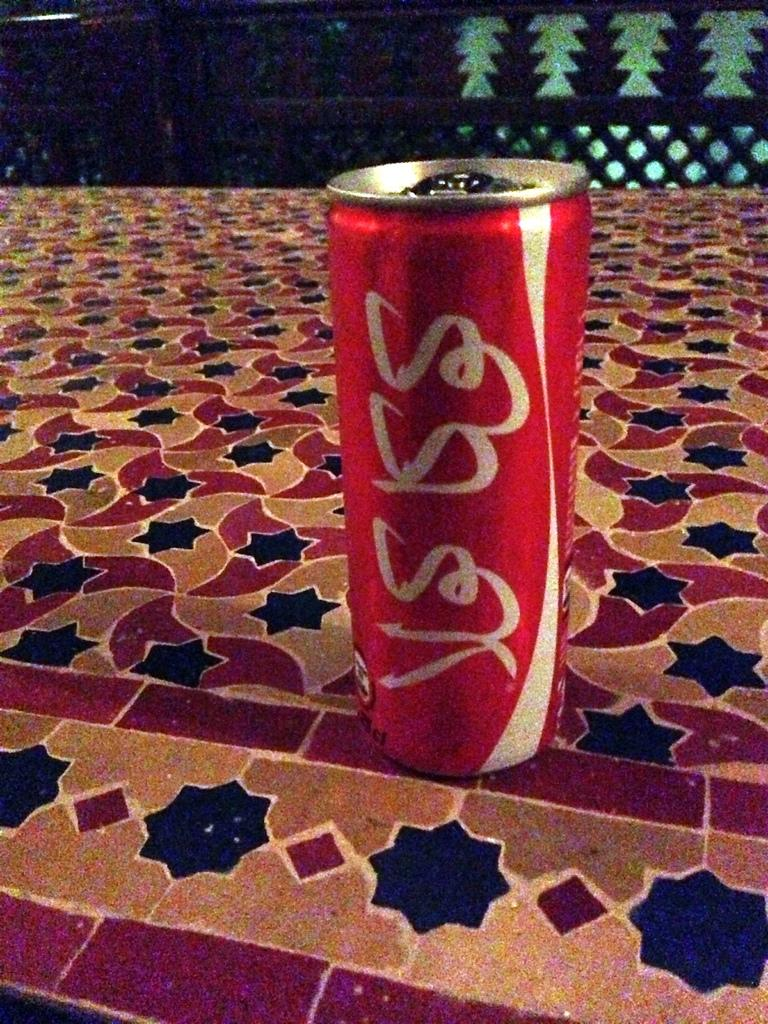<image>
Offer a succinct explanation of the picture presented. A can of coca cola with what looks like YESS sits on the ground. 